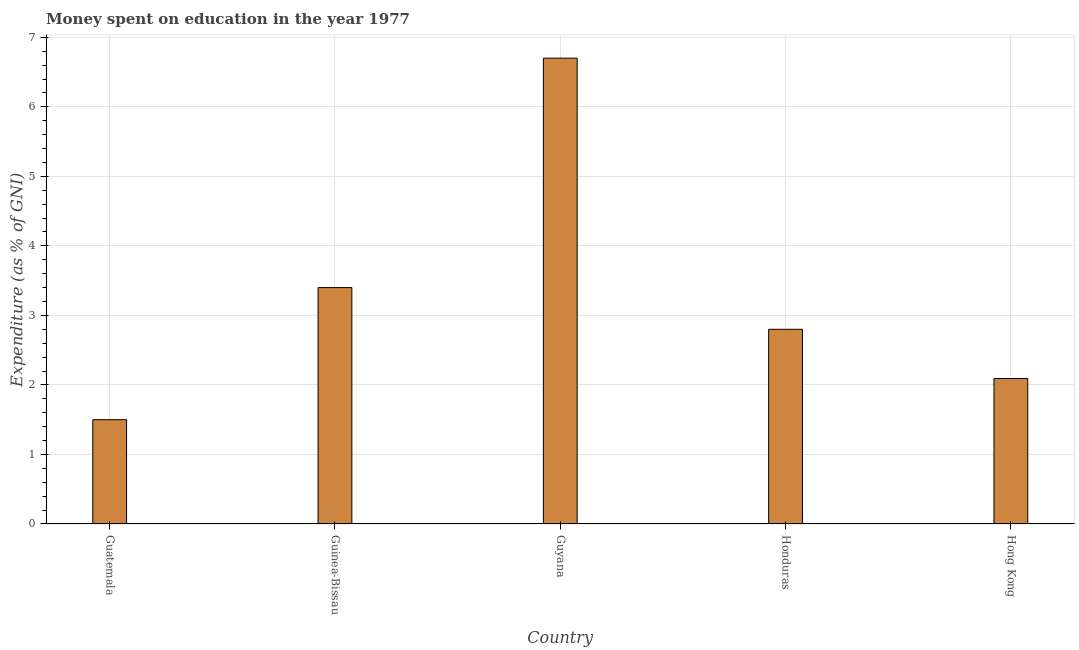Does the graph contain grids?
Your answer should be compact. Yes. What is the title of the graph?
Provide a short and direct response. Money spent on education in the year 1977. What is the label or title of the X-axis?
Give a very brief answer. Country. What is the label or title of the Y-axis?
Your response must be concise. Expenditure (as % of GNI). Across all countries, what is the maximum expenditure on education?
Your answer should be very brief. 6.7. Across all countries, what is the minimum expenditure on education?
Keep it short and to the point. 1.5. In which country was the expenditure on education maximum?
Keep it short and to the point. Guyana. In which country was the expenditure on education minimum?
Your answer should be compact. Guatemala. What is the sum of the expenditure on education?
Provide a succinct answer. 16.49. What is the difference between the expenditure on education in Guinea-Bissau and Hong Kong?
Offer a terse response. 1.31. What is the average expenditure on education per country?
Your answer should be compact. 3.3. What is the ratio of the expenditure on education in Guatemala to that in Honduras?
Offer a terse response. 0.54. How many countries are there in the graph?
Give a very brief answer. 5. What is the Expenditure (as % of GNI) of Guatemala?
Ensure brevity in your answer.  1.5. What is the Expenditure (as % of GNI) in Guinea-Bissau?
Offer a very short reply. 3.4. What is the Expenditure (as % of GNI) in Guyana?
Ensure brevity in your answer.  6.7. What is the Expenditure (as % of GNI) in Hong Kong?
Your answer should be compact. 2.09. What is the difference between the Expenditure (as % of GNI) in Guatemala and Guinea-Bissau?
Your response must be concise. -1.9. What is the difference between the Expenditure (as % of GNI) in Guatemala and Guyana?
Ensure brevity in your answer.  -5.2. What is the difference between the Expenditure (as % of GNI) in Guatemala and Hong Kong?
Keep it short and to the point. -0.59. What is the difference between the Expenditure (as % of GNI) in Guinea-Bissau and Guyana?
Give a very brief answer. -3.3. What is the difference between the Expenditure (as % of GNI) in Guinea-Bissau and Honduras?
Your answer should be very brief. 0.6. What is the difference between the Expenditure (as % of GNI) in Guinea-Bissau and Hong Kong?
Give a very brief answer. 1.31. What is the difference between the Expenditure (as % of GNI) in Guyana and Hong Kong?
Offer a very short reply. 4.61. What is the difference between the Expenditure (as % of GNI) in Honduras and Hong Kong?
Your answer should be compact. 0.71. What is the ratio of the Expenditure (as % of GNI) in Guatemala to that in Guinea-Bissau?
Give a very brief answer. 0.44. What is the ratio of the Expenditure (as % of GNI) in Guatemala to that in Guyana?
Provide a succinct answer. 0.22. What is the ratio of the Expenditure (as % of GNI) in Guatemala to that in Honduras?
Provide a short and direct response. 0.54. What is the ratio of the Expenditure (as % of GNI) in Guatemala to that in Hong Kong?
Make the answer very short. 0.72. What is the ratio of the Expenditure (as % of GNI) in Guinea-Bissau to that in Guyana?
Your answer should be very brief. 0.51. What is the ratio of the Expenditure (as % of GNI) in Guinea-Bissau to that in Honduras?
Make the answer very short. 1.21. What is the ratio of the Expenditure (as % of GNI) in Guinea-Bissau to that in Hong Kong?
Ensure brevity in your answer.  1.62. What is the ratio of the Expenditure (as % of GNI) in Guyana to that in Honduras?
Offer a terse response. 2.39. What is the ratio of the Expenditure (as % of GNI) in Guyana to that in Hong Kong?
Ensure brevity in your answer.  3.2. What is the ratio of the Expenditure (as % of GNI) in Honduras to that in Hong Kong?
Your answer should be very brief. 1.34. 